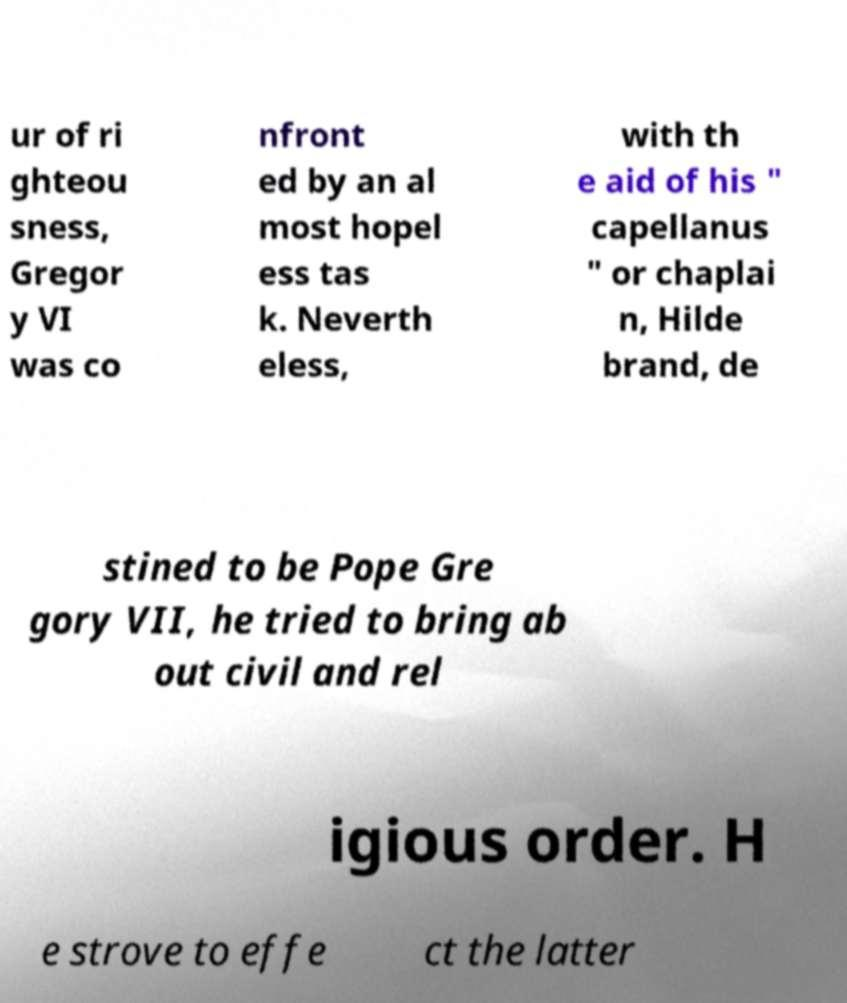Could you assist in decoding the text presented in this image and type it out clearly? ur of ri ghteou sness, Gregor y VI was co nfront ed by an al most hopel ess tas k. Neverth eless, with th e aid of his " capellanus " or chaplai n, Hilde brand, de stined to be Pope Gre gory VII, he tried to bring ab out civil and rel igious order. H e strove to effe ct the latter 